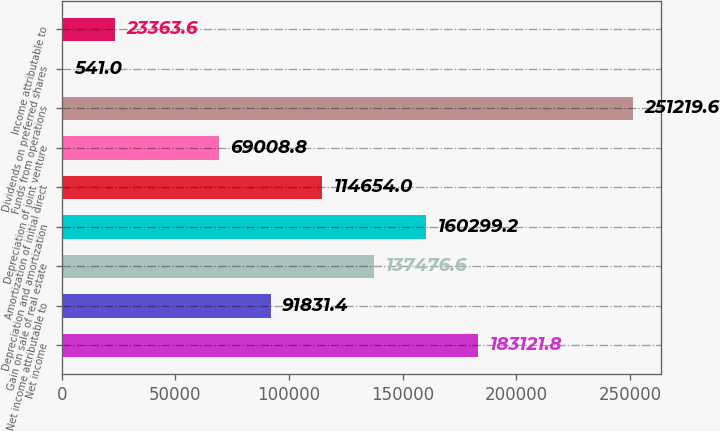Convert chart. <chart><loc_0><loc_0><loc_500><loc_500><bar_chart><fcel>Net income<fcel>Net income attributable to<fcel>Gain on sale of real estate<fcel>Depreciation and amortization<fcel>Amortization of initial direct<fcel>Depreciation of joint venture<fcel>Funds from operations<fcel>Dividends on preferred shares<fcel>Income attributable to<nl><fcel>183122<fcel>91831.4<fcel>137477<fcel>160299<fcel>114654<fcel>69008.8<fcel>251220<fcel>541<fcel>23363.6<nl></chart> 